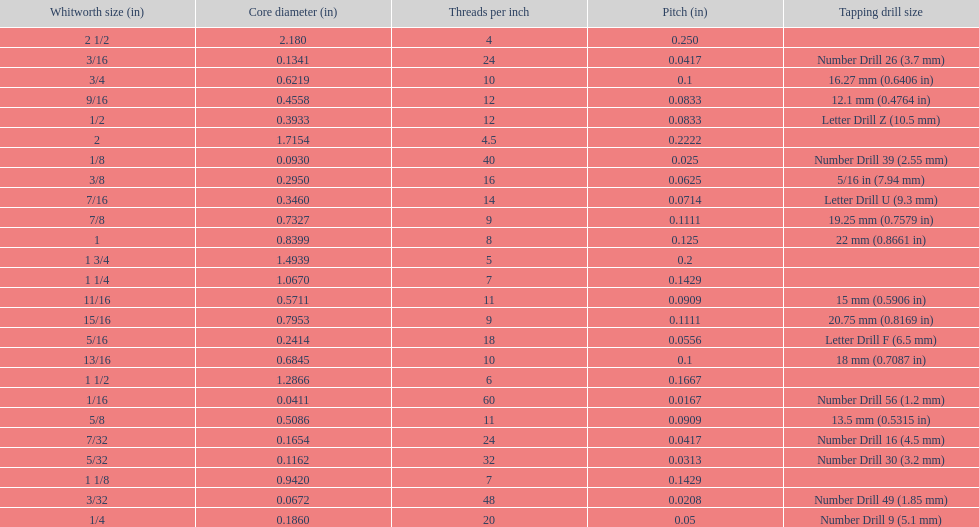What is the core diameter of the first 1/8 whitworth size (in)? 0.0930. 